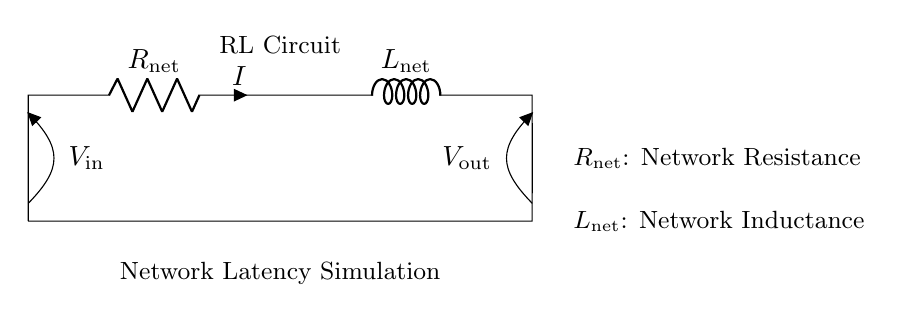What are the components in this circuit? The components visible in the circuit diagram are a resistor and an inductor, specifically labeled as R_net and L_net.
Answer: Resistor, Inductor What is the purpose of R_net? R_net represents network resistance, which in this context simulates latency in a network by impeding current flow.
Answer: Network Resistance What is the purpose of L_net? L_net signifies network inductance, which stores energy in a magnetic field when current flows, influencing the circuit's response to changes in current.
Answer: Network Inductance What does V_in represent in the diagram? V_in is the input voltage, which is applied across the resistor R_net and determines the current flow through the circuit depending on the resistance.
Answer: Input Voltage What happens to current in an RL circuit after a voltage is applied? The current rises gradually due to the inductor's property of opposing changes in current flow, causing a time delay dependent on R_net and L_net values.
Answer: Gradual increase What is the effect of increasing R_net on the circuit's latency simulation? Increasing R_net raises the resistance, which causes a longer delay in the current rise time, as more resistance results in a slower response to voltage changes.
Answer: Longer delay What is the relationship between V_out and the inductor L_net? The output voltage V_out depends on the energy stored in L_net, which affects how much voltage drops across the inductor based on the current flow and rate of change.
Answer: Dependent on current change 